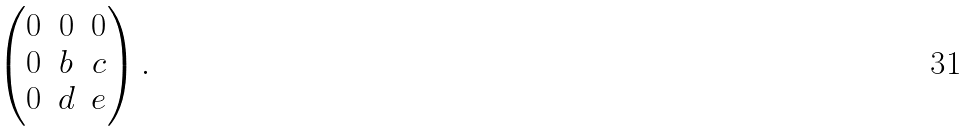Convert formula to latex. <formula><loc_0><loc_0><loc_500><loc_500>\begin{pmatrix} 0 & 0 & 0 \\ 0 & b & c \\ 0 & d & e \end{pmatrix} .</formula> 